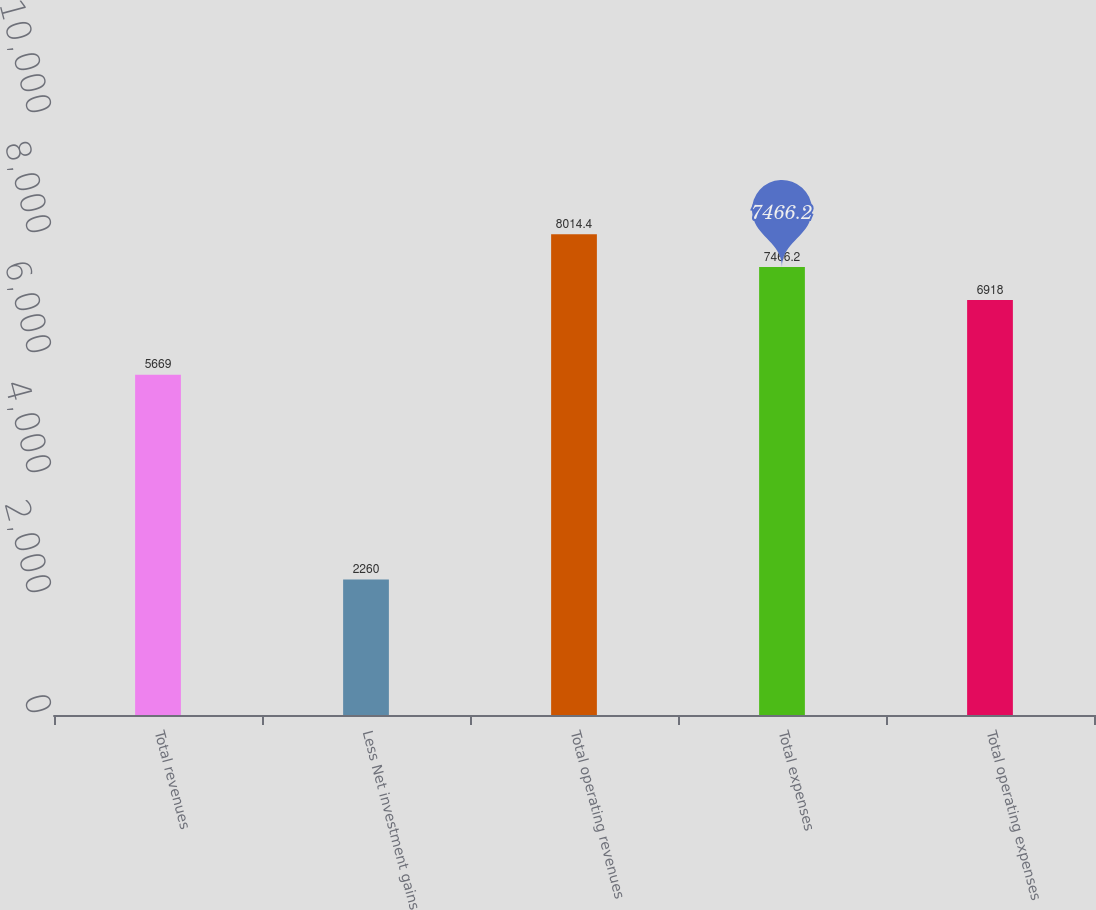<chart> <loc_0><loc_0><loc_500><loc_500><bar_chart><fcel>Total revenues<fcel>Less Net investment gains<fcel>Total operating revenues<fcel>Total expenses<fcel>Total operating expenses<nl><fcel>5669<fcel>2260<fcel>8014.4<fcel>7466.2<fcel>6918<nl></chart> 